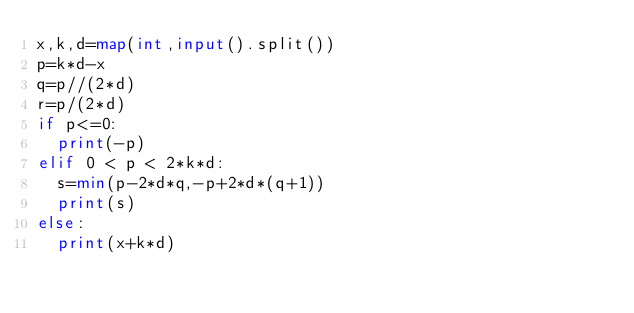<code> <loc_0><loc_0><loc_500><loc_500><_Python_>x,k,d=map(int,input().split())
p=k*d-x
q=p//(2*d)
r=p/(2*d)
if p<=0:
  print(-p)
elif 0 < p < 2*k*d:
  s=min(p-2*d*q,-p+2*d*(q+1))
  print(s)
else:
  print(x+k*d)
</code> 